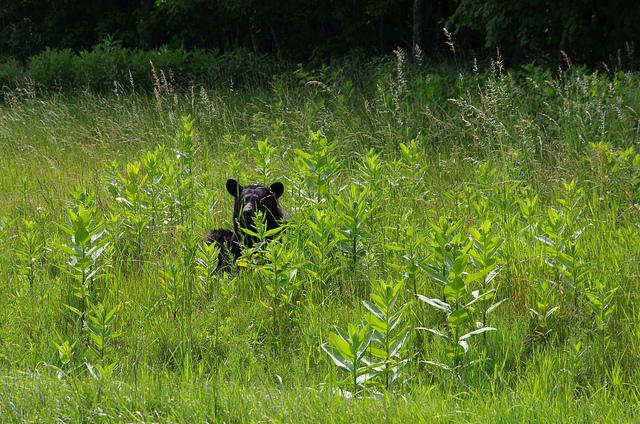Are there flowers?
Give a very brief answer. No. Is the grass high?
Answer briefly. Yes. Are all the bears facing the camera?
Give a very brief answer. Yes. Where are these bears doing?
Write a very short answer. Hiding. Is there a polar bear in the picture?
Short answer required. No. What is peeking out of the grass?
Keep it brief. Bear. What are the bears looking for?
Concise answer only. Food. What animal is pictured?
Quick response, please. Bear. 